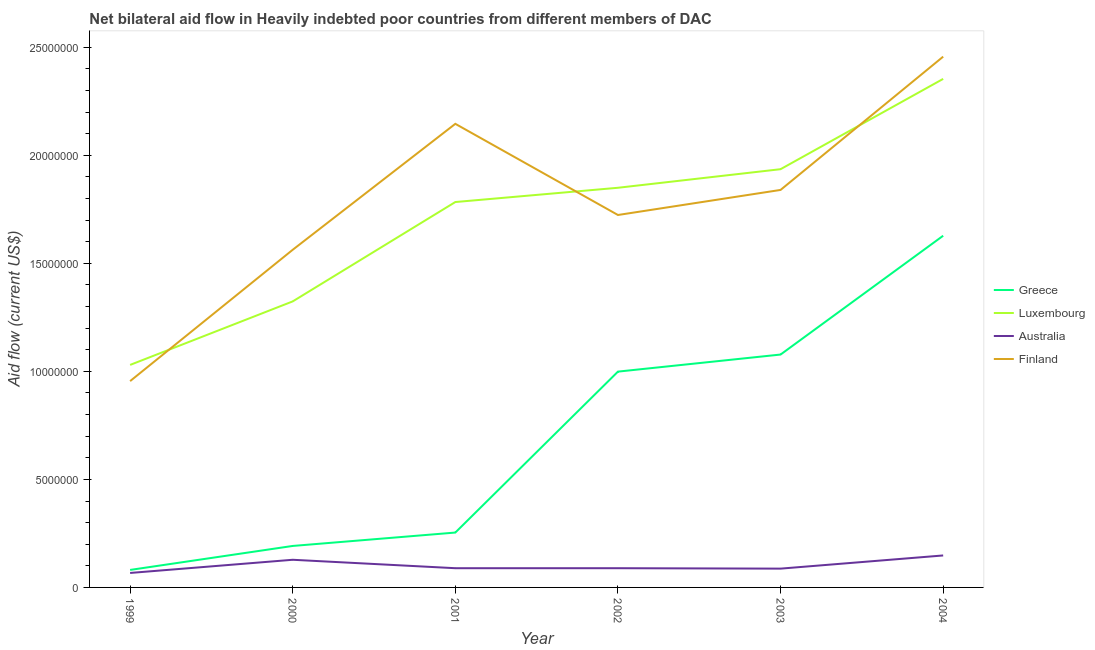Does the line corresponding to amount of aid given by greece intersect with the line corresponding to amount of aid given by australia?
Make the answer very short. No. What is the amount of aid given by finland in 1999?
Your response must be concise. 9.55e+06. Across all years, what is the maximum amount of aid given by australia?
Make the answer very short. 1.48e+06. Across all years, what is the minimum amount of aid given by finland?
Provide a short and direct response. 9.55e+06. In which year was the amount of aid given by finland minimum?
Give a very brief answer. 1999. What is the total amount of aid given by greece in the graph?
Give a very brief answer. 4.23e+07. What is the difference between the amount of aid given by australia in 2002 and that in 2003?
Make the answer very short. 2.00e+04. What is the difference between the amount of aid given by finland in 2002 and the amount of aid given by luxembourg in 2000?
Offer a very short reply. 4.00e+06. What is the average amount of aid given by finland per year?
Your answer should be compact. 1.78e+07. In the year 1999, what is the difference between the amount of aid given by luxembourg and amount of aid given by finland?
Keep it short and to the point. 7.50e+05. In how many years, is the amount of aid given by finland greater than 12000000 US$?
Give a very brief answer. 5. What is the ratio of the amount of aid given by australia in 2003 to that in 2004?
Provide a short and direct response. 0.59. What is the difference between the highest and the second highest amount of aid given by luxembourg?
Your answer should be compact. 4.18e+06. What is the difference between the highest and the lowest amount of aid given by finland?
Provide a succinct answer. 1.50e+07. Is it the case that in every year, the sum of the amount of aid given by greece and amount of aid given by finland is greater than the sum of amount of aid given by australia and amount of aid given by luxembourg?
Your answer should be compact. No. Is it the case that in every year, the sum of the amount of aid given by greece and amount of aid given by luxembourg is greater than the amount of aid given by australia?
Your answer should be very brief. Yes. Does the amount of aid given by greece monotonically increase over the years?
Offer a terse response. Yes. Is the amount of aid given by finland strictly greater than the amount of aid given by greece over the years?
Your response must be concise. Yes. Are the values on the major ticks of Y-axis written in scientific E-notation?
Make the answer very short. No. Does the graph contain any zero values?
Make the answer very short. No. Where does the legend appear in the graph?
Make the answer very short. Center right. How are the legend labels stacked?
Provide a succinct answer. Vertical. What is the title of the graph?
Provide a succinct answer. Net bilateral aid flow in Heavily indebted poor countries from different members of DAC. Does "Offering training" appear as one of the legend labels in the graph?
Your answer should be very brief. No. What is the Aid flow (current US$) in Greece in 1999?
Keep it short and to the point. 8.10e+05. What is the Aid flow (current US$) of Luxembourg in 1999?
Offer a very short reply. 1.03e+07. What is the Aid flow (current US$) in Australia in 1999?
Your answer should be compact. 6.70e+05. What is the Aid flow (current US$) in Finland in 1999?
Make the answer very short. 9.55e+06. What is the Aid flow (current US$) in Greece in 2000?
Provide a succinct answer. 1.92e+06. What is the Aid flow (current US$) of Luxembourg in 2000?
Your response must be concise. 1.32e+07. What is the Aid flow (current US$) of Australia in 2000?
Offer a terse response. 1.28e+06. What is the Aid flow (current US$) of Finland in 2000?
Your answer should be compact. 1.56e+07. What is the Aid flow (current US$) in Greece in 2001?
Ensure brevity in your answer.  2.54e+06. What is the Aid flow (current US$) in Luxembourg in 2001?
Give a very brief answer. 1.78e+07. What is the Aid flow (current US$) in Australia in 2001?
Offer a very short reply. 8.90e+05. What is the Aid flow (current US$) in Finland in 2001?
Keep it short and to the point. 2.15e+07. What is the Aid flow (current US$) of Greece in 2002?
Offer a very short reply. 9.99e+06. What is the Aid flow (current US$) of Luxembourg in 2002?
Your answer should be very brief. 1.85e+07. What is the Aid flow (current US$) in Australia in 2002?
Offer a very short reply. 8.90e+05. What is the Aid flow (current US$) in Finland in 2002?
Keep it short and to the point. 1.72e+07. What is the Aid flow (current US$) in Greece in 2003?
Keep it short and to the point. 1.08e+07. What is the Aid flow (current US$) in Luxembourg in 2003?
Give a very brief answer. 1.94e+07. What is the Aid flow (current US$) in Australia in 2003?
Ensure brevity in your answer.  8.70e+05. What is the Aid flow (current US$) of Finland in 2003?
Your answer should be very brief. 1.84e+07. What is the Aid flow (current US$) in Greece in 2004?
Give a very brief answer. 1.63e+07. What is the Aid flow (current US$) in Luxembourg in 2004?
Your response must be concise. 2.35e+07. What is the Aid flow (current US$) of Australia in 2004?
Keep it short and to the point. 1.48e+06. What is the Aid flow (current US$) in Finland in 2004?
Ensure brevity in your answer.  2.46e+07. Across all years, what is the maximum Aid flow (current US$) of Greece?
Your answer should be very brief. 1.63e+07. Across all years, what is the maximum Aid flow (current US$) of Luxembourg?
Your answer should be very brief. 2.35e+07. Across all years, what is the maximum Aid flow (current US$) in Australia?
Provide a succinct answer. 1.48e+06. Across all years, what is the maximum Aid flow (current US$) of Finland?
Your answer should be very brief. 2.46e+07. Across all years, what is the minimum Aid flow (current US$) of Greece?
Ensure brevity in your answer.  8.10e+05. Across all years, what is the minimum Aid flow (current US$) in Luxembourg?
Ensure brevity in your answer.  1.03e+07. Across all years, what is the minimum Aid flow (current US$) of Australia?
Offer a very short reply. 6.70e+05. Across all years, what is the minimum Aid flow (current US$) in Finland?
Provide a short and direct response. 9.55e+06. What is the total Aid flow (current US$) of Greece in the graph?
Your answer should be compact. 4.23e+07. What is the total Aid flow (current US$) in Luxembourg in the graph?
Make the answer very short. 1.03e+08. What is the total Aid flow (current US$) of Australia in the graph?
Your answer should be very brief. 6.08e+06. What is the total Aid flow (current US$) in Finland in the graph?
Provide a succinct answer. 1.07e+08. What is the difference between the Aid flow (current US$) of Greece in 1999 and that in 2000?
Give a very brief answer. -1.11e+06. What is the difference between the Aid flow (current US$) in Luxembourg in 1999 and that in 2000?
Make the answer very short. -2.94e+06. What is the difference between the Aid flow (current US$) in Australia in 1999 and that in 2000?
Ensure brevity in your answer.  -6.10e+05. What is the difference between the Aid flow (current US$) of Finland in 1999 and that in 2000?
Provide a short and direct response. -6.08e+06. What is the difference between the Aid flow (current US$) of Greece in 1999 and that in 2001?
Provide a succinct answer. -1.73e+06. What is the difference between the Aid flow (current US$) of Luxembourg in 1999 and that in 2001?
Give a very brief answer. -7.54e+06. What is the difference between the Aid flow (current US$) of Australia in 1999 and that in 2001?
Offer a very short reply. -2.20e+05. What is the difference between the Aid flow (current US$) in Finland in 1999 and that in 2001?
Give a very brief answer. -1.19e+07. What is the difference between the Aid flow (current US$) in Greece in 1999 and that in 2002?
Provide a succinct answer. -9.18e+06. What is the difference between the Aid flow (current US$) in Luxembourg in 1999 and that in 2002?
Offer a very short reply. -8.20e+06. What is the difference between the Aid flow (current US$) of Finland in 1999 and that in 2002?
Your answer should be compact. -7.69e+06. What is the difference between the Aid flow (current US$) in Greece in 1999 and that in 2003?
Your answer should be compact. -9.97e+06. What is the difference between the Aid flow (current US$) of Luxembourg in 1999 and that in 2003?
Provide a succinct answer. -9.06e+06. What is the difference between the Aid flow (current US$) of Australia in 1999 and that in 2003?
Keep it short and to the point. -2.00e+05. What is the difference between the Aid flow (current US$) in Finland in 1999 and that in 2003?
Offer a very short reply. -8.85e+06. What is the difference between the Aid flow (current US$) in Greece in 1999 and that in 2004?
Keep it short and to the point. -1.55e+07. What is the difference between the Aid flow (current US$) in Luxembourg in 1999 and that in 2004?
Give a very brief answer. -1.32e+07. What is the difference between the Aid flow (current US$) of Australia in 1999 and that in 2004?
Provide a short and direct response. -8.10e+05. What is the difference between the Aid flow (current US$) in Finland in 1999 and that in 2004?
Give a very brief answer. -1.50e+07. What is the difference between the Aid flow (current US$) of Greece in 2000 and that in 2001?
Your answer should be very brief. -6.20e+05. What is the difference between the Aid flow (current US$) of Luxembourg in 2000 and that in 2001?
Provide a succinct answer. -4.60e+06. What is the difference between the Aid flow (current US$) of Finland in 2000 and that in 2001?
Give a very brief answer. -5.83e+06. What is the difference between the Aid flow (current US$) of Greece in 2000 and that in 2002?
Your response must be concise. -8.07e+06. What is the difference between the Aid flow (current US$) in Luxembourg in 2000 and that in 2002?
Provide a short and direct response. -5.26e+06. What is the difference between the Aid flow (current US$) in Finland in 2000 and that in 2002?
Offer a terse response. -1.61e+06. What is the difference between the Aid flow (current US$) of Greece in 2000 and that in 2003?
Make the answer very short. -8.86e+06. What is the difference between the Aid flow (current US$) in Luxembourg in 2000 and that in 2003?
Your answer should be compact. -6.12e+06. What is the difference between the Aid flow (current US$) in Finland in 2000 and that in 2003?
Offer a very short reply. -2.77e+06. What is the difference between the Aid flow (current US$) of Greece in 2000 and that in 2004?
Your answer should be very brief. -1.44e+07. What is the difference between the Aid flow (current US$) in Luxembourg in 2000 and that in 2004?
Ensure brevity in your answer.  -1.03e+07. What is the difference between the Aid flow (current US$) in Australia in 2000 and that in 2004?
Your answer should be very brief. -2.00e+05. What is the difference between the Aid flow (current US$) of Finland in 2000 and that in 2004?
Your response must be concise. -8.94e+06. What is the difference between the Aid flow (current US$) in Greece in 2001 and that in 2002?
Offer a terse response. -7.45e+06. What is the difference between the Aid flow (current US$) of Luxembourg in 2001 and that in 2002?
Make the answer very short. -6.60e+05. What is the difference between the Aid flow (current US$) of Australia in 2001 and that in 2002?
Give a very brief answer. 0. What is the difference between the Aid flow (current US$) of Finland in 2001 and that in 2002?
Your answer should be very brief. 4.22e+06. What is the difference between the Aid flow (current US$) of Greece in 2001 and that in 2003?
Your response must be concise. -8.24e+06. What is the difference between the Aid flow (current US$) in Luxembourg in 2001 and that in 2003?
Your answer should be compact. -1.52e+06. What is the difference between the Aid flow (current US$) of Australia in 2001 and that in 2003?
Your response must be concise. 2.00e+04. What is the difference between the Aid flow (current US$) of Finland in 2001 and that in 2003?
Make the answer very short. 3.06e+06. What is the difference between the Aid flow (current US$) of Greece in 2001 and that in 2004?
Keep it short and to the point. -1.37e+07. What is the difference between the Aid flow (current US$) of Luxembourg in 2001 and that in 2004?
Keep it short and to the point. -5.70e+06. What is the difference between the Aid flow (current US$) of Australia in 2001 and that in 2004?
Provide a succinct answer. -5.90e+05. What is the difference between the Aid flow (current US$) of Finland in 2001 and that in 2004?
Offer a very short reply. -3.11e+06. What is the difference between the Aid flow (current US$) of Greece in 2002 and that in 2003?
Offer a very short reply. -7.90e+05. What is the difference between the Aid flow (current US$) in Luxembourg in 2002 and that in 2003?
Your response must be concise. -8.60e+05. What is the difference between the Aid flow (current US$) in Finland in 2002 and that in 2003?
Your answer should be compact. -1.16e+06. What is the difference between the Aid flow (current US$) of Greece in 2002 and that in 2004?
Offer a very short reply. -6.29e+06. What is the difference between the Aid flow (current US$) in Luxembourg in 2002 and that in 2004?
Provide a succinct answer. -5.04e+06. What is the difference between the Aid flow (current US$) in Australia in 2002 and that in 2004?
Your response must be concise. -5.90e+05. What is the difference between the Aid flow (current US$) in Finland in 2002 and that in 2004?
Provide a succinct answer. -7.33e+06. What is the difference between the Aid flow (current US$) in Greece in 2003 and that in 2004?
Offer a terse response. -5.50e+06. What is the difference between the Aid flow (current US$) of Luxembourg in 2003 and that in 2004?
Your answer should be very brief. -4.18e+06. What is the difference between the Aid flow (current US$) in Australia in 2003 and that in 2004?
Your answer should be very brief. -6.10e+05. What is the difference between the Aid flow (current US$) in Finland in 2003 and that in 2004?
Make the answer very short. -6.17e+06. What is the difference between the Aid flow (current US$) in Greece in 1999 and the Aid flow (current US$) in Luxembourg in 2000?
Offer a very short reply. -1.24e+07. What is the difference between the Aid flow (current US$) in Greece in 1999 and the Aid flow (current US$) in Australia in 2000?
Give a very brief answer. -4.70e+05. What is the difference between the Aid flow (current US$) of Greece in 1999 and the Aid flow (current US$) of Finland in 2000?
Ensure brevity in your answer.  -1.48e+07. What is the difference between the Aid flow (current US$) of Luxembourg in 1999 and the Aid flow (current US$) of Australia in 2000?
Ensure brevity in your answer.  9.02e+06. What is the difference between the Aid flow (current US$) in Luxembourg in 1999 and the Aid flow (current US$) in Finland in 2000?
Ensure brevity in your answer.  -5.33e+06. What is the difference between the Aid flow (current US$) of Australia in 1999 and the Aid flow (current US$) of Finland in 2000?
Ensure brevity in your answer.  -1.50e+07. What is the difference between the Aid flow (current US$) of Greece in 1999 and the Aid flow (current US$) of Luxembourg in 2001?
Your answer should be very brief. -1.70e+07. What is the difference between the Aid flow (current US$) in Greece in 1999 and the Aid flow (current US$) in Australia in 2001?
Your response must be concise. -8.00e+04. What is the difference between the Aid flow (current US$) of Greece in 1999 and the Aid flow (current US$) of Finland in 2001?
Provide a short and direct response. -2.06e+07. What is the difference between the Aid flow (current US$) of Luxembourg in 1999 and the Aid flow (current US$) of Australia in 2001?
Your answer should be compact. 9.41e+06. What is the difference between the Aid flow (current US$) of Luxembourg in 1999 and the Aid flow (current US$) of Finland in 2001?
Your answer should be compact. -1.12e+07. What is the difference between the Aid flow (current US$) of Australia in 1999 and the Aid flow (current US$) of Finland in 2001?
Your answer should be very brief. -2.08e+07. What is the difference between the Aid flow (current US$) in Greece in 1999 and the Aid flow (current US$) in Luxembourg in 2002?
Make the answer very short. -1.77e+07. What is the difference between the Aid flow (current US$) in Greece in 1999 and the Aid flow (current US$) in Australia in 2002?
Offer a very short reply. -8.00e+04. What is the difference between the Aid flow (current US$) of Greece in 1999 and the Aid flow (current US$) of Finland in 2002?
Your response must be concise. -1.64e+07. What is the difference between the Aid flow (current US$) of Luxembourg in 1999 and the Aid flow (current US$) of Australia in 2002?
Give a very brief answer. 9.41e+06. What is the difference between the Aid flow (current US$) in Luxembourg in 1999 and the Aid flow (current US$) in Finland in 2002?
Your answer should be very brief. -6.94e+06. What is the difference between the Aid flow (current US$) of Australia in 1999 and the Aid flow (current US$) of Finland in 2002?
Offer a very short reply. -1.66e+07. What is the difference between the Aid flow (current US$) of Greece in 1999 and the Aid flow (current US$) of Luxembourg in 2003?
Provide a succinct answer. -1.86e+07. What is the difference between the Aid flow (current US$) of Greece in 1999 and the Aid flow (current US$) of Finland in 2003?
Give a very brief answer. -1.76e+07. What is the difference between the Aid flow (current US$) in Luxembourg in 1999 and the Aid flow (current US$) in Australia in 2003?
Offer a very short reply. 9.43e+06. What is the difference between the Aid flow (current US$) in Luxembourg in 1999 and the Aid flow (current US$) in Finland in 2003?
Make the answer very short. -8.10e+06. What is the difference between the Aid flow (current US$) in Australia in 1999 and the Aid flow (current US$) in Finland in 2003?
Give a very brief answer. -1.77e+07. What is the difference between the Aid flow (current US$) of Greece in 1999 and the Aid flow (current US$) of Luxembourg in 2004?
Your response must be concise. -2.27e+07. What is the difference between the Aid flow (current US$) of Greece in 1999 and the Aid flow (current US$) of Australia in 2004?
Your answer should be very brief. -6.70e+05. What is the difference between the Aid flow (current US$) in Greece in 1999 and the Aid flow (current US$) in Finland in 2004?
Ensure brevity in your answer.  -2.38e+07. What is the difference between the Aid flow (current US$) in Luxembourg in 1999 and the Aid flow (current US$) in Australia in 2004?
Provide a short and direct response. 8.82e+06. What is the difference between the Aid flow (current US$) in Luxembourg in 1999 and the Aid flow (current US$) in Finland in 2004?
Provide a short and direct response. -1.43e+07. What is the difference between the Aid flow (current US$) in Australia in 1999 and the Aid flow (current US$) in Finland in 2004?
Make the answer very short. -2.39e+07. What is the difference between the Aid flow (current US$) of Greece in 2000 and the Aid flow (current US$) of Luxembourg in 2001?
Provide a short and direct response. -1.59e+07. What is the difference between the Aid flow (current US$) in Greece in 2000 and the Aid flow (current US$) in Australia in 2001?
Your response must be concise. 1.03e+06. What is the difference between the Aid flow (current US$) in Greece in 2000 and the Aid flow (current US$) in Finland in 2001?
Your answer should be very brief. -1.95e+07. What is the difference between the Aid flow (current US$) in Luxembourg in 2000 and the Aid flow (current US$) in Australia in 2001?
Your answer should be very brief. 1.24e+07. What is the difference between the Aid flow (current US$) in Luxembourg in 2000 and the Aid flow (current US$) in Finland in 2001?
Offer a terse response. -8.22e+06. What is the difference between the Aid flow (current US$) in Australia in 2000 and the Aid flow (current US$) in Finland in 2001?
Make the answer very short. -2.02e+07. What is the difference between the Aid flow (current US$) of Greece in 2000 and the Aid flow (current US$) of Luxembourg in 2002?
Provide a short and direct response. -1.66e+07. What is the difference between the Aid flow (current US$) of Greece in 2000 and the Aid flow (current US$) of Australia in 2002?
Provide a succinct answer. 1.03e+06. What is the difference between the Aid flow (current US$) in Greece in 2000 and the Aid flow (current US$) in Finland in 2002?
Make the answer very short. -1.53e+07. What is the difference between the Aid flow (current US$) of Luxembourg in 2000 and the Aid flow (current US$) of Australia in 2002?
Keep it short and to the point. 1.24e+07. What is the difference between the Aid flow (current US$) of Australia in 2000 and the Aid flow (current US$) of Finland in 2002?
Give a very brief answer. -1.60e+07. What is the difference between the Aid flow (current US$) of Greece in 2000 and the Aid flow (current US$) of Luxembourg in 2003?
Give a very brief answer. -1.74e+07. What is the difference between the Aid flow (current US$) in Greece in 2000 and the Aid flow (current US$) in Australia in 2003?
Provide a succinct answer. 1.05e+06. What is the difference between the Aid flow (current US$) of Greece in 2000 and the Aid flow (current US$) of Finland in 2003?
Keep it short and to the point. -1.65e+07. What is the difference between the Aid flow (current US$) of Luxembourg in 2000 and the Aid flow (current US$) of Australia in 2003?
Your answer should be very brief. 1.24e+07. What is the difference between the Aid flow (current US$) in Luxembourg in 2000 and the Aid flow (current US$) in Finland in 2003?
Ensure brevity in your answer.  -5.16e+06. What is the difference between the Aid flow (current US$) of Australia in 2000 and the Aid flow (current US$) of Finland in 2003?
Offer a very short reply. -1.71e+07. What is the difference between the Aid flow (current US$) of Greece in 2000 and the Aid flow (current US$) of Luxembourg in 2004?
Offer a very short reply. -2.16e+07. What is the difference between the Aid flow (current US$) in Greece in 2000 and the Aid flow (current US$) in Finland in 2004?
Offer a very short reply. -2.26e+07. What is the difference between the Aid flow (current US$) in Luxembourg in 2000 and the Aid flow (current US$) in Australia in 2004?
Your answer should be very brief. 1.18e+07. What is the difference between the Aid flow (current US$) in Luxembourg in 2000 and the Aid flow (current US$) in Finland in 2004?
Offer a very short reply. -1.13e+07. What is the difference between the Aid flow (current US$) of Australia in 2000 and the Aid flow (current US$) of Finland in 2004?
Make the answer very short. -2.33e+07. What is the difference between the Aid flow (current US$) of Greece in 2001 and the Aid flow (current US$) of Luxembourg in 2002?
Make the answer very short. -1.60e+07. What is the difference between the Aid flow (current US$) of Greece in 2001 and the Aid flow (current US$) of Australia in 2002?
Offer a terse response. 1.65e+06. What is the difference between the Aid flow (current US$) in Greece in 2001 and the Aid flow (current US$) in Finland in 2002?
Offer a very short reply. -1.47e+07. What is the difference between the Aid flow (current US$) of Luxembourg in 2001 and the Aid flow (current US$) of Australia in 2002?
Your answer should be very brief. 1.70e+07. What is the difference between the Aid flow (current US$) of Luxembourg in 2001 and the Aid flow (current US$) of Finland in 2002?
Offer a very short reply. 6.00e+05. What is the difference between the Aid flow (current US$) of Australia in 2001 and the Aid flow (current US$) of Finland in 2002?
Your answer should be compact. -1.64e+07. What is the difference between the Aid flow (current US$) in Greece in 2001 and the Aid flow (current US$) in Luxembourg in 2003?
Your response must be concise. -1.68e+07. What is the difference between the Aid flow (current US$) of Greece in 2001 and the Aid flow (current US$) of Australia in 2003?
Offer a terse response. 1.67e+06. What is the difference between the Aid flow (current US$) in Greece in 2001 and the Aid flow (current US$) in Finland in 2003?
Provide a short and direct response. -1.59e+07. What is the difference between the Aid flow (current US$) in Luxembourg in 2001 and the Aid flow (current US$) in Australia in 2003?
Provide a short and direct response. 1.70e+07. What is the difference between the Aid flow (current US$) in Luxembourg in 2001 and the Aid flow (current US$) in Finland in 2003?
Ensure brevity in your answer.  -5.60e+05. What is the difference between the Aid flow (current US$) in Australia in 2001 and the Aid flow (current US$) in Finland in 2003?
Ensure brevity in your answer.  -1.75e+07. What is the difference between the Aid flow (current US$) in Greece in 2001 and the Aid flow (current US$) in Luxembourg in 2004?
Offer a terse response. -2.10e+07. What is the difference between the Aid flow (current US$) of Greece in 2001 and the Aid flow (current US$) of Australia in 2004?
Ensure brevity in your answer.  1.06e+06. What is the difference between the Aid flow (current US$) in Greece in 2001 and the Aid flow (current US$) in Finland in 2004?
Provide a short and direct response. -2.20e+07. What is the difference between the Aid flow (current US$) in Luxembourg in 2001 and the Aid flow (current US$) in Australia in 2004?
Provide a succinct answer. 1.64e+07. What is the difference between the Aid flow (current US$) of Luxembourg in 2001 and the Aid flow (current US$) of Finland in 2004?
Offer a terse response. -6.73e+06. What is the difference between the Aid flow (current US$) of Australia in 2001 and the Aid flow (current US$) of Finland in 2004?
Keep it short and to the point. -2.37e+07. What is the difference between the Aid flow (current US$) in Greece in 2002 and the Aid flow (current US$) in Luxembourg in 2003?
Ensure brevity in your answer.  -9.37e+06. What is the difference between the Aid flow (current US$) in Greece in 2002 and the Aid flow (current US$) in Australia in 2003?
Offer a terse response. 9.12e+06. What is the difference between the Aid flow (current US$) of Greece in 2002 and the Aid flow (current US$) of Finland in 2003?
Your answer should be compact. -8.41e+06. What is the difference between the Aid flow (current US$) of Luxembourg in 2002 and the Aid flow (current US$) of Australia in 2003?
Provide a short and direct response. 1.76e+07. What is the difference between the Aid flow (current US$) in Australia in 2002 and the Aid flow (current US$) in Finland in 2003?
Provide a succinct answer. -1.75e+07. What is the difference between the Aid flow (current US$) of Greece in 2002 and the Aid flow (current US$) of Luxembourg in 2004?
Keep it short and to the point. -1.36e+07. What is the difference between the Aid flow (current US$) of Greece in 2002 and the Aid flow (current US$) of Australia in 2004?
Keep it short and to the point. 8.51e+06. What is the difference between the Aid flow (current US$) of Greece in 2002 and the Aid flow (current US$) of Finland in 2004?
Ensure brevity in your answer.  -1.46e+07. What is the difference between the Aid flow (current US$) in Luxembourg in 2002 and the Aid flow (current US$) in Australia in 2004?
Keep it short and to the point. 1.70e+07. What is the difference between the Aid flow (current US$) of Luxembourg in 2002 and the Aid flow (current US$) of Finland in 2004?
Your response must be concise. -6.07e+06. What is the difference between the Aid flow (current US$) of Australia in 2002 and the Aid flow (current US$) of Finland in 2004?
Offer a very short reply. -2.37e+07. What is the difference between the Aid flow (current US$) in Greece in 2003 and the Aid flow (current US$) in Luxembourg in 2004?
Offer a very short reply. -1.28e+07. What is the difference between the Aid flow (current US$) in Greece in 2003 and the Aid flow (current US$) in Australia in 2004?
Ensure brevity in your answer.  9.30e+06. What is the difference between the Aid flow (current US$) of Greece in 2003 and the Aid flow (current US$) of Finland in 2004?
Offer a very short reply. -1.38e+07. What is the difference between the Aid flow (current US$) of Luxembourg in 2003 and the Aid flow (current US$) of Australia in 2004?
Keep it short and to the point. 1.79e+07. What is the difference between the Aid flow (current US$) of Luxembourg in 2003 and the Aid flow (current US$) of Finland in 2004?
Offer a terse response. -5.21e+06. What is the difference between the Aid flow (current US$) of Australia in 2003 and the Aid flow (current US$) of Finland in 2004?
Give a very brief answer. -2.37e+07. What is the average Aid flow (current US$) in Greece per year?
Ensure brevity in your answer.  7.05e+06. What is the average Aid flow (current US$) in Luxembourg per year?
Your answer should be very brief. 1.71e+07. What is the average Aid flow (current US$) of Australia per year?
Give a very brief answer. 1.01e+06. What is the average Aid flow (current US$) in Finland per year?
Provide a succinct answer. 1.78e+07. In the year 1999, what is the difference between the Aid flow (current US$) in Greece and Aid flow (current US$) in Luxembourg?
Your answer should be compact. -9.49e+06. In the year 1999, what is the difference between the Aid flow (current US$) of Greece and Aid flow (current US$) of Finland?
Your response must be concise. -8.74e+06. In the year 1999, what is the difference between the Aid flow (current US$) in Luxembourg and Aid flow (current US$) in Australia?
Provide a short and direct response. 9.63e+06. In the year 1999, what is the difference between the Aid flow (current US$) of Luxembourg and Aid flow (current US$) of Finland?
Offer a very short reply. 7.50e+05. In the year 1999, what is the difference between the Aid flow (current US$) of Australia and Aid flow (current US$) of Finland?
Provide a succinct answer. -8.88e+06. In the year 2000, what is the difference between the Aid flow (current US$) in Greece and Aid flow (current US$) in Luxembourg?
Offer a very short reply. -1.13e+07. In the year 2000, what is the difference between the Aid flow (current US$) of Greece and Aid flow (current US$) of Australia?
Provide a succinct answer. 6.40e+05. In the year 2000, what is the difference between the Aid flow (current US$) in Greece and Aid flow (current US$) in Finland?
Provide a succinct answer. -1.37e+07. In the year 2000, what is the difference between the Aid flow (current US$) in Luxembourg and Aid flow (current US$) in Australia?
Make the answer very short. 1.20e+07. In the year 2000, what is the difference between the Aid flow (current US$) in Luxembourg and Aid flow (current US$) in Finland?
Your answer should be very brief. -2.39e+06. In the year 2000, what is the difference between the Aid flow (current US$) of Australia and Aid flow (current US$) of Finland?
Provide a short and direct response. -1.44e+07. In the year 2001, what is the difference between the Aid flow (current US$) of Greece and Aid flow (current US$) of Luxembourg?
Keep it short and to the point. -1.53e+07. In the year 2001, what is the difference between the Aid flow (current US$) in Greece and Aid flow (current US$) in Australia?
Make the answer very short. 1.65e+06. In the year 2001, what is the difference between the Aid flow (current US$) of Greece and Aid flow (current US$) of Finland?
Offer a very short reply. -1.89e+07. In the year 2001, what is the difference between the Aid flow (current US$) in Luxembourg and Aid flow (current US$) in Australia?
Your answer should be very brief. 1.70e+07. In the year 2001, what is the difference between the Aid flow (current US$) in Luxembourg and Aid flow (current US$) in Finland?
Provide a short and direct response. -3.62e+06. In the year 2001, what is the difference between the Aid flow (current US$) of Australia and Aid flow (current US$) of Finland?
Give a very brief answer. -2.06e+07. In the year 2002, what is the difference between the Aid flow (current US$) in Greece and Aid flow (current US$) in Luxembourg?
Your answer should be very brief. -8.51e+06. In the year 2002, what is the difference between the Aid flow (current US$) in Greece and Aid flow (current US$) in Australia?
Offer a very short reply. 9.10e+06. In the year 2002, what is the difference between the Aid flow (current US$) of Greece and Aid flow (current US$) of Finland?
Provide a succinct answer. -7.25e+06. In the year 2002, what is the difference between the Aid flow (current US$) in Luxembourg and Aid flow (current US$) in Australia?
Keep it short and to the point. 1.76e+07. In the year 2002, what is the difference between the Aid flow (current US$) of Luxembourg and Aid flow (current US$) of Finland?
Your answer should be compact. 1.26e+06. In the year 2002, what is the difference between the Aid flow (current US$) of Australia and Aid flow (current US$) of Finland?
Your response must be concise. -1.64e+07. In the year 2003, what is the difference between the Aid flow (current US$) of Greece and Aid flow (current US$) of Luxembourg?
Provide a short and direct response. -8.58e+06. In the year 2003, what is the difference between the Aid flow (current US$) in Greece and Aid flow (current US$) in Australia?
Provide a short and direct response. 9.91e+06. In the year 2003, what is the difference between the Aid flow (current US$) in Greece and Aid flow (current US$) in Finland?
Give a very brief answer. -7.62e+06. In the year 2003, what is the difference between the Aid flow (current US$) in Luxembourg and Aid flow (current US$) in Australia?
Offer a terse response. 1.85e+07. In the year 2003, what is the difference between the Aid flow (current US$) in Luxembourg and Aid flow (current US$) in Finland?
Offer a terse response. 9.60e+05. In the year 2003, what is the difference between the Aid flow (current US$) in Australia and Aid flow (current US$) in Finland?
Your answer should be very brief. -1.75e+07. In the year 2004, what is the difference between the Aid flow (current US$) in Greece and Aid flow (current US$) in Luxembourg?
Offer a terse response. -7.26e+06. In the year 2004, what is the difference between the Aid flow (current US$) of Greece and Aid flow (current US$) of Australia?
Keep it short and to the point. 1.48e+07. In the year 2004, what is the difference between the Aid flow (current US$) in Greece and Aid flow (current US$) in Finland?
Offer a terse response. -8.29e+06. In the year 2004, what is the difference between the Aid flow (current US$) of Luxembourg and Aid flow (current US$) of Australia?
Provide a succinct answer. 2.21e+07. In the year 2004, what is the difference between the Aid flow (current US$) of Luxembourg and Aid flow (current US$) of Finland?
Your response must be concise. -1.03e+06. In the year 2004, what is the difference between the Aid flow (current US$) in Australia and Aid flow (current US$) in Finland?
Keep it short and to the point. -2.31e+07. What is the ratio of the Aid flow (current US$) of Greece in 1999 to that in 2000?
Make the answer very short. 0.42. What is the ratio of the Aid flow (current US$) of Luxembourg in 1999 to that in 2000?
Offer a terse response. 0.78. What is the ratio of the Aid flow (current US$) of Australia in 1999 to that in 2000?
Offer a terse response. 0.52. What is the ratio of the Aid flow (current US$) of Finland in 1999 to that in 2000?
Give a very brief answer. 0.61. What is the ratio of the Aid flow (current US$) of Greece in 1999 to that in 2001?
Give a very brief answer. 0.32. What is the ratio of the Aid flow (current US$) in Luxembourg in 1999 to that in 2001?
Make the answer very short. 0.58. What is the ratio of the Aid flow (current US$) in Australia in 1999 to that in 2001?
Your answer should be very brief. 0.75. What is the ratio of the Aid flow (current US$) of Finland in 1999 to that in 2001?
Offer a very short reply. 0.45. What is the ratio of the Aid flow (current US$) in Greece in 1999 to that in 2002?
Ensure brevity in your answer.  0.08. What is the ratio of the Aid flow (current US$) in Luxembourg in 1999 to that in 2002?
Offer a terse response. 0.56. What is the ratio of the Aid flow (current US$) in Australia in 1999 to that in 2002?
Offer a terse response. 0.75. What is the ratio of the Aid flow (current US$) in Finland in 1999 to that in 2002?
Your response must be concise. 0.55. What is the ratio of the Aid flow (current US$) of Greece in 1999 to that in 2003?
Offer a very short reply. 0.08. What is the ratio of the Aid flow (current US$) of Luxembourg in 1999 to that in 2003?
Offer a very short reply. 0.53. What is the ratio of the Aid flow (current US$) of Australia in 1999 to that in 2003?
Your answer should be compact. 0.77. What is the ratio of the Aid flow (current US$) in Finland in 1999 to that in 2003?
Your answer should be compact. 0.52. What is the ratio of the Aid flow (current US$) of Greece in 1999 to that in 2004?
Ensure brevity in your answer.  0.05. What is the ratio of the Aid flow (current US$) of Luxembourg in 1999 to that in 2004?
Provide a succinct answer. 0.44. What is the ratio of the Aid flow (current US$) of Australia in 1999 to that in 2004?
Provide a short and direct response. 0.45. What is the ratio of the Aid flow (current US$) in Finland in 1999 to that in 2004?
Provide a succinct answer. 0.39. What is the ratio of the Aid flow (current US$) in Greece in 2000 to that in 2001?
Provide a short and direct response. 0.76. What is the ratio of the Aid flow (current US$) of Luxembourg in 2000 to that in 2001?
Provide a succinct answer. 0.74. What is the ratio of the Aid flow (current US$) in Australia in 2000 to that in 2001?
Keep it short and to the point. 1.44. What is the ratio of the Aid flow (current US$) of Finland in 2000 to that in 2001?
Provide a succinct answer. 0.73. What is the ratio of the Aid flow (current US$) of Greece in 2000 to that in 2002?
Give a very brief answer. 0.19. What is the ratio of the Aid flow (current US$) of Luxembourg in 2000 to that in 2002?
Your answer should be compact. 0.72. What is the ratio of the Aid flow (current US$) in Australia in 2000 to that in 2002?
Your answer should be very brief. 1.44. What is the ratio of the Aid flow (current US$) of Finland in 2000 to that in 2002?
Make the answer very short. 0.91. What is the ratio of the Aid flow (current US$) of Greece in 2000 to that in 2003?
Offer a terse response. 0.18. What is the ratio of the Aid flow (current US$) in Luxembourg in 2000 to that in 2003?
Make the answer very short. 0.68. What is the ratio of the Aid flow (current US$) of Australia in 2000 to that in 2003?
Your response must be concise. 1.47. What is the ratio of the Aid flow (current US$) in Finland in 2000 to that in 2003?
Offer a very short reply. 0.85. What is the ratio of the Aid flow (current US$) in Greece in 2000 to that in 2004?
Give a very brief answer. 0.12. What is the ratio of the Aid flow (current US$) in Luxembourg in 2000 to that in 2004?
Offer a terse response. 0.56. What is the ratio of the Aid flow (current US$) in Australia in 2000 to that in 2004?
Make the answer very short. 0.86. What is the ratio of the Aid flow (current US$) in Finland in 2000 to that in 2004?
Your response must be concise. 0.64. What is the ratio of the Aid flow (current US$) of Greece in 2001 to that in 2002?
Provide a succinct answer. 0.25. What is the ratio of the Aid flow (current US$) of Luxembourg in 2001 to that in 2002?
Keep it short and to the point. 0.96. What is the ratio of the Aid flow (current US$) of Australia in 2001 to that in 2002?
Ensure brevity in your answer.  1. What is the ratio of the Aid flow (current US$) of Finland in 2001 to that in 2002?
Offer a terse response. 1.24. What is the ratio of the Aid flow (current US$) in Greece in 2001 to that in 2003?
Offer a terse response. 0.24. What is the ratio of the Aid flow (current US$) in Luxembourg in 2001 to that in 2003?
Offer a terse response. 0.92. What is the ratio of the Aid flow (current US$) in Finland in 2001 to that in 2003?
Ensure brevity in your answer.  1.17. What is the ratio of the Aid flow (current US$) of Greece in 2001 to that in 2004?
Offer a very short reply. 0.16. What is the ratio of the Aid flow (current US$) in Luxembourg in 2001 to that in 2004?
Keep it short and to the point. 0.76. What is the ratio of the Aid flow (current US$) of Australia in 2001 to that in 2004?
Provide a short and direct response. 0.6. What is the ratio of the Aid flow (current US$) in Finland in 2001 to that in 2004?
Your response must be concise. 0.87. What is the ratio of the Aid flow (current US$) in Greece in 2002 to that in 2003?
Provide a short and direct response. 0.93. What is the ratio of the Aid flow (current US$) of Luxembourg in 2002 to that in 2003?
Offer a terse response. 0.96. What is the ratio of the Aid flow (current US$) of Australia in 2002 to that in 2003?
Give a very brief answer. 1.02. What is the ratio of the Aid flow (current US$) in Finland in 2002 to that in 2003?
Your answer should be very brief. 0.94. What is the ratio of the Aid flow (current US$) in Greece in 2002 to that in 2004?
Your answer should be compact. 0.61. What is the ratio of the Aid flow (current US$) of Luxembourg in 2002 to that in 2004?
Provide a succinct answer. 0.79. What is the ratio of the Aid flow (current US$) of Australia in 2002 to that in 2004?
Keep it short and to the point. 0.6. What is the ratio of the Aid flow (current US$) of Finland in 2002 to that in 2004?
Your answer should be compact. 0.7. What is the ratio of the Aid flow (current US$) of Greece in 2003 to that in 2004?
Provide a short and direct response. 0.66. What is the ratio of the Aid flow (current US$) in Luxembourg in 2003 to that in 2004?
Offer a very short reply. 0.82. What is the ratio of the Aid flow (current US$) of Australia in 2003 to that in 2004?
Your answer should be very brief. 0.59. What is the ratio of the Aid flow (current US$) of Finland in 2003 to that in 2004?
Offer a terse response. 0.75. What is the difference between the highest and the second highest Aid flow (current US$) of Greece?
Your response must be concise. 5.50e+06. What is the difference between the highest and the second highest Aid flow (current US$) of Luxembourg?
Make the answer very short. 4.18e+06. What is the difference between the highest and the second highest Aid flow (current US$) of Finland?
Keep it short and to the point. 3.11e+06. What is the difference between the highest and the lowest Aid flow (current US$) in Greece?
Make the answer very short. 1.55e+07. What is the difference between the highest and the lowest Aid flow (current US$) of Luxembourg?
Provide a succinct answer. 1.32e+07. What is the difference between the highest and the lowest Aid flow (current US$) of Australia?
Give a very brief answer. 8.10e+05. What is the difference between the highest and the lowest Aid flow (current US$) in Finland?
Keep it short and to the point. 1.50e+07. 